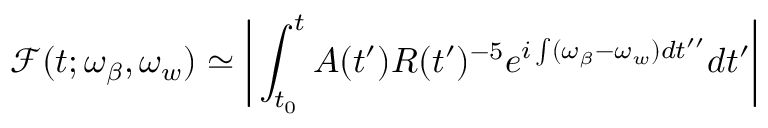<formula> <loc_0><loc_0><loc_500><loc_500>\mathcal { F } ( t ; \omega _ { \beta } , \omega _ { w } ) \simeq \left | \int _ { t _ { 0 } } ^ { t } A ( t ^ { \prime } ) R ( t ^ { \prime } ) ^ { - 5 } e ^ { i \int ( \omega _ { \beta } - \omega _ { w } ) d t ^ { \prime \prime } } d t ^ { \prime } \right |</formula> 